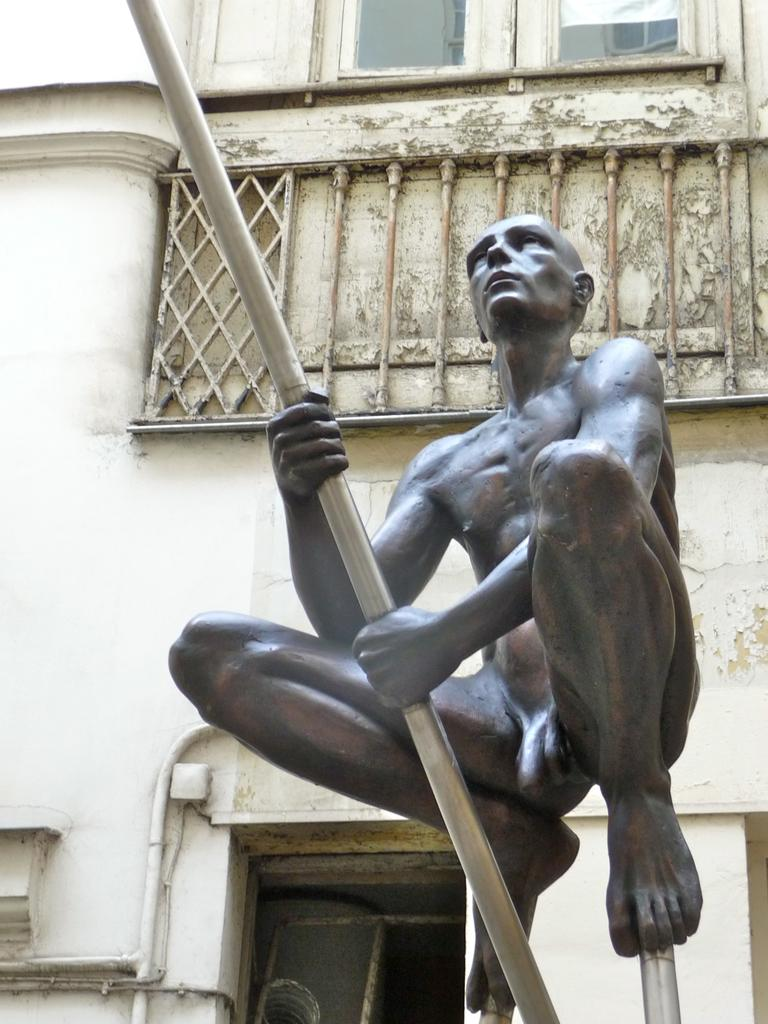What is the statue in the image depicting? The statue is of a person jumping and holding a pipe. Where might the statue be located? The statue is likely to be in front of a building. What can be observed about the building in the image? The building has windows. Is there any other object related to the statue's theme in the image? Yes, there is a pipe attached to the wall. What type of chin can be seen on the tiger in the image? There is no tiger present in the image, and therefore no chin to observe. What type of vegetable is being held by the person in the statue? The statue depicts a person holding a pipe, not a vegetable. 